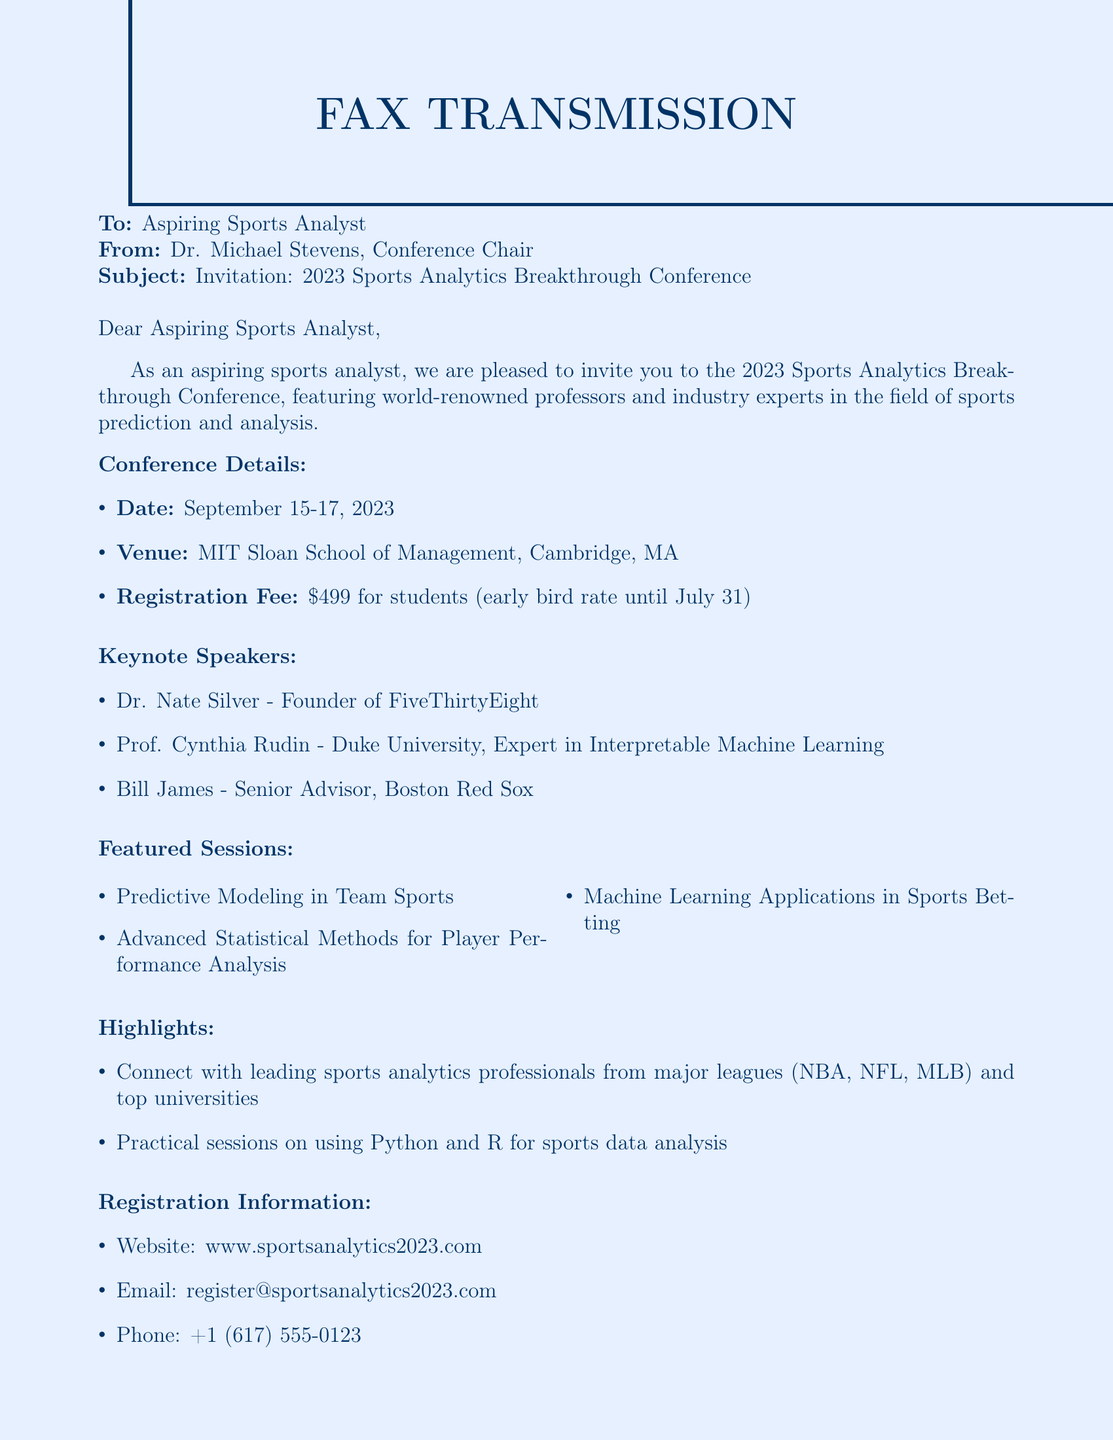what are the conference dates? The conference is scheduled for three days, as mentioned: September 15-17, 2023.
Answer: September 15-17, 2023 who is one of the keynote speakers? The document lists three keynote speakers, one of whom is Dr. Nate Silver.
Answer: Dr. Nate Silver what is the registration fee for students? The document specifies the registration fee for students as $499, with an early bird rate until July 31.
Answer: $499 which university is Prof. Cynthia Rudin affiliated with? The document states that Prof. Cynthia Rudin is from Duke University.
Answer: Duke University what is one highlight of the conference? The highlights include connecting with sports analytics professionals from major leagues, among other activities.
Answer: Connect with leading sports analytics professionals what is the venue for the conference? The document mentions that the venue is MIT Sloan School of Management, Cambridge, MA.
Answer: MIT Sloan School of Management, Cambridge, MA what type of sessions will be offered at the conference? The document lists various sessions, highlighting "Predictive Modeling in Team Sports" as an example.
Answer: Predictive Modeling in Team Sports what is the email for registration inquiries? The document provides an email address for registration inquiries as register@sportsanalytics2023.com.
Answer: register@sportsanalytics2023.com 